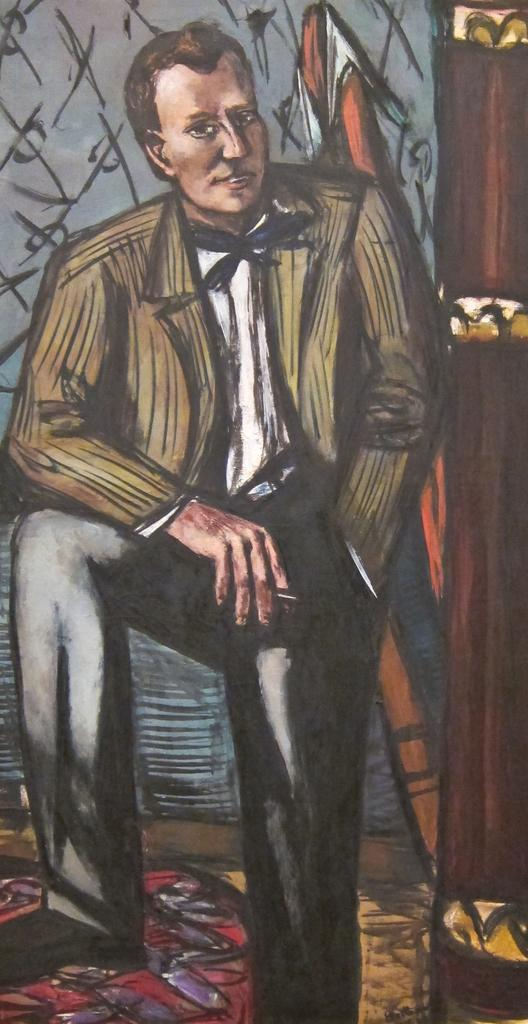What is depicted in the image? The image contains a sketch of a person. What is the person in the sketch doing? The person is standing in the sketch. What is the background of the image? The sketch is placed over a background. How is the sketch presented? The sketch is colored. What type of pig can be seen playing in a band in the image? There is no pig or band present in the image; it features a sketch of a person standing over a background. 